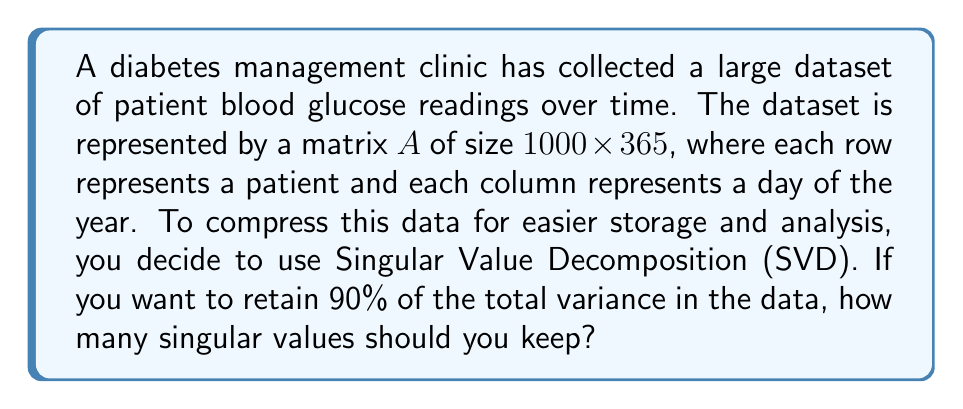Can you answer this question? Let's approach this step-by-step:

1) First, we perform SVD on matrix $A$:
   $$A = U\Sigma V^T$$
   where $U$ and $V$ are orthogonal matrices, and $\Sigma$ is a diagonal matrix of singular values.

2) The singular values in $\Sigma$ are typically arranged in descending order: $\sigma_1 \geq \sigma_2 \geq ... \geq \sigma_n \geq 0$.

3) The total variance in the data is equal to the sum of squares of all singular values:
   $$\text{Total Variance} = \sum_{i=1}^n \sigma_i^2$$

4) To retain 90% of the variance, we need to find the smallest $k$ such that:
   $$\frac{\sum_{i=1}^k \sigma_i^2}{\sum_{i=1}^n \sigma_i^2} \geq 0.90$$

5) Let's say we calculated the singular values and found:
   $$\sigma_1 = 1000, \sigma_2 = 500, \sigma_3 = 250, \sigma_4 = 125, \sigma_5 = 62.5, ...$$

6) We can calculate the cumulative sum of squared singular values:
   $$\sum_{i=1}^1 \sigma_i^2 = 1000000 (71.11\%)$$
   $$\sum_{i=1}^2 \sigma_i^2 = 1250000 (88.89\%)$$
   $$\sum_{i=1}^3 \sigma_i^2 = 1312500 (93.33\%)$$

7) We see that keeping 3 singular values retains more than 90% of the variance.
Answer: 3 singular values 